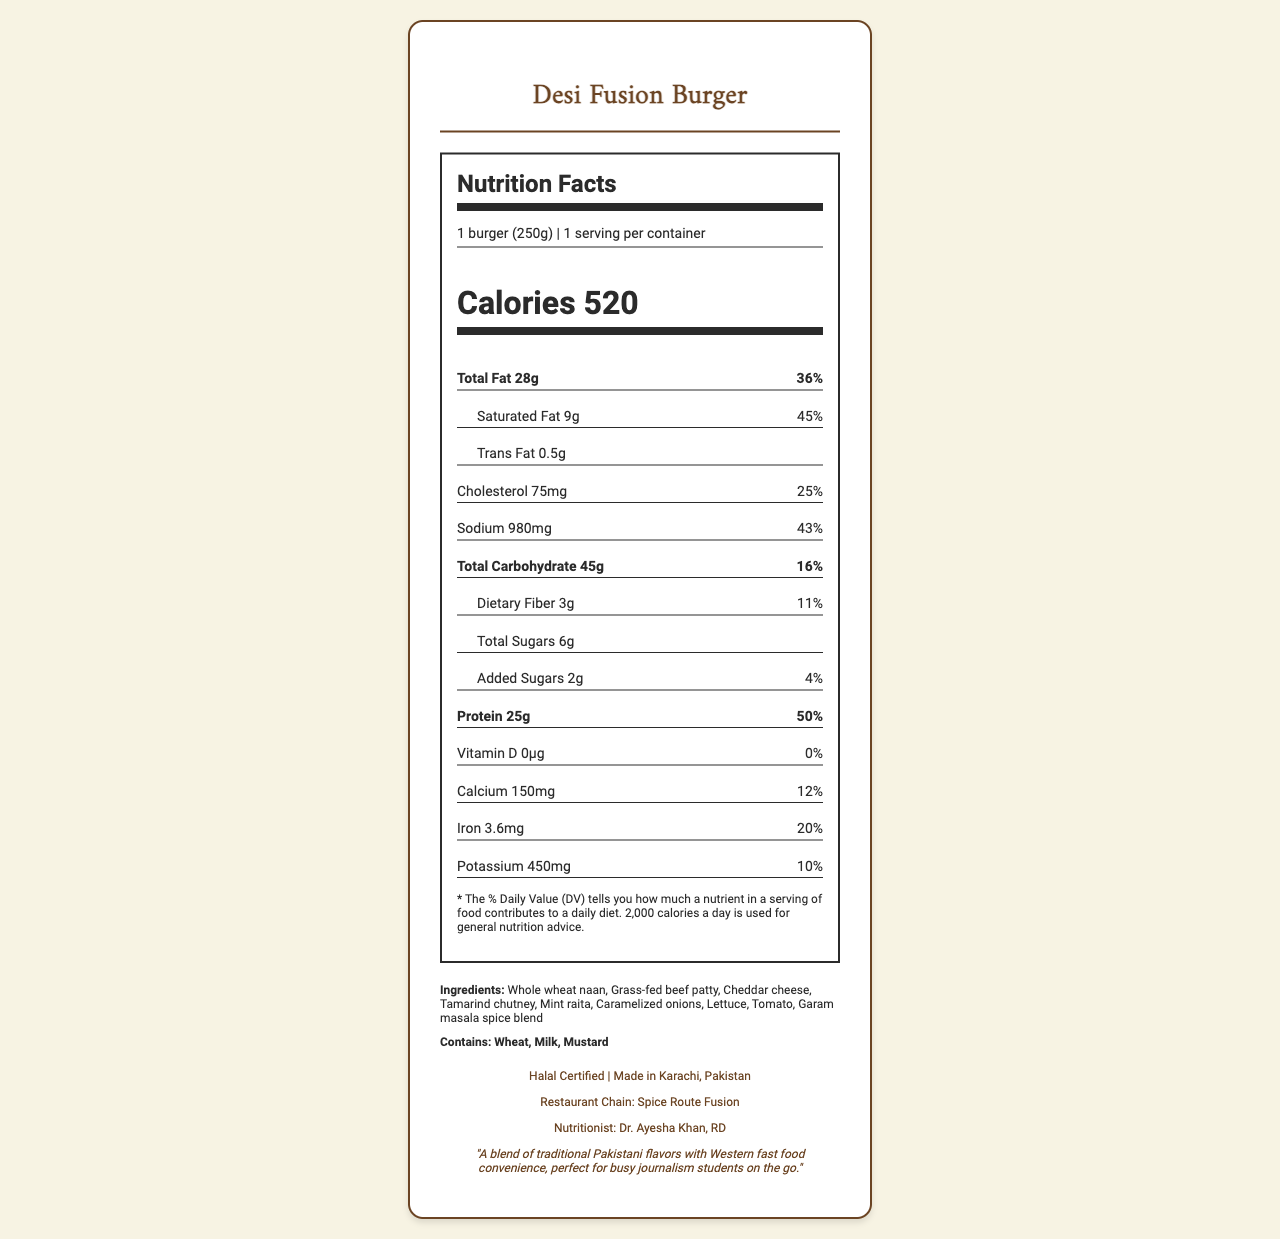what is the total calorie count of the Desi Fusion Burger? The nutrition label indicates that 1 serving of the Desi Fusion Burger (which is 1 burger) contains 520 calories.
Answer: 520 how much trans fat is in the Desi Fusion Burger? According to the nutrition label, the burger contains 0.5 grams of trans fat per serving.
Answer: 0.5 grams What percent of the daily value for saturated fat does the Desi Fusion Burger offer? The nutrition label shows that the saturated fat content is 9 grams, which is 45% of the daily value.
Answer: 45% what is the primary ingredient in the Desi Fusion Burger? The ingredients list starts with "Whole wheat naan," suggesting it is the primary ingredient.
Answer: Whole wheat naan which country is the Desi Fusion Burger made in? The "additional info" section clearly states that the burger is made in Karachi, Pakistan.
Answer: Pakistan which nutrient has the highest daily value percentage in the Desi Fusion Burger? The protein content is 25 grams, contributing 50% of the daily value, the highest percentage listed.
Answer: Protein what are the allergens listed for the Desi Fusion Burger? The allergens section states the Desi Fusion Burger contains wheat, milk, and mustard.
Answer: Wheat, Milk, Mustard how much sodium does the Desi Fusion Burger contain? The nutrition label details that the burger contains 980 milligrams of sodium.
Answer: 980 milligrams how many grams of dietary fiber are in the Desi Fusion Burger? The nutrition label specifies that there are 3 grams of dietary fiber in the burger.
Answer: 3 grams For which nutrient does the Desi Fusion Burger provide no daily value contribution? A. Vitamin D B. Calcium C. Iron The nutrition label shows that vitamin D has 0 micrograms and 0% daily value, while calcium and iron have relevant contributions.
Answer: A. Vitamin D how many servings per container are mentioned? The nutrition label notes that there is one serving per container, which is one burger.
Answer: 1 who is the nutritionist behind the Desi Fusion Burger? A. Dr. Ayesha Khan B. Dr. Shahida Qazi C. Dr. Hamza Ali The "additional info" section identifies Dr. Ayesha Khan, RD, as the nutritionist.
Answer: A. Dr. Ayesha Khan is the Desi Fusion Burger halal certified? The "additional info" section clearly states that the burger is halal certified.
Answer: Yes summarize the main idea of the document. The document is a nutrition facts label for the Desi Fusion Burger, specifying its nutritional content, ingredients, and additional product details aimed at providing essential information for consumers.
Answer: The document provides detailed nutrition information for the Desi Fusion Burger, a blend of Pakistani and Western fast food. It lists the serving size, calorie count, and various nutrients along with their daily values. Also, it mentions the ingredients, allergens, and additional product information including its halal certification and origin. how many grams of protein are there in one serving of the Desi Fusion Burger? The nutrition label states that there are 25 grams of protein per serving.
Answer: 25 grams who inspired the creation of the Desi Fusion Burger? The document does not mention any individual's inspiration for the creation of the Desi Fusion Burger, only a general inspiration that blends Pakistani and Western flavors for busy students.
Answer: Not enough information how many grams of total carbohydrates are in the Desi Fusion Burger? A. 28 grams B. 25 grams C. 45 grams The nutrition label shows that the total carbohydrate content is 45 grams per serving.
Answer: C. 45 grams 